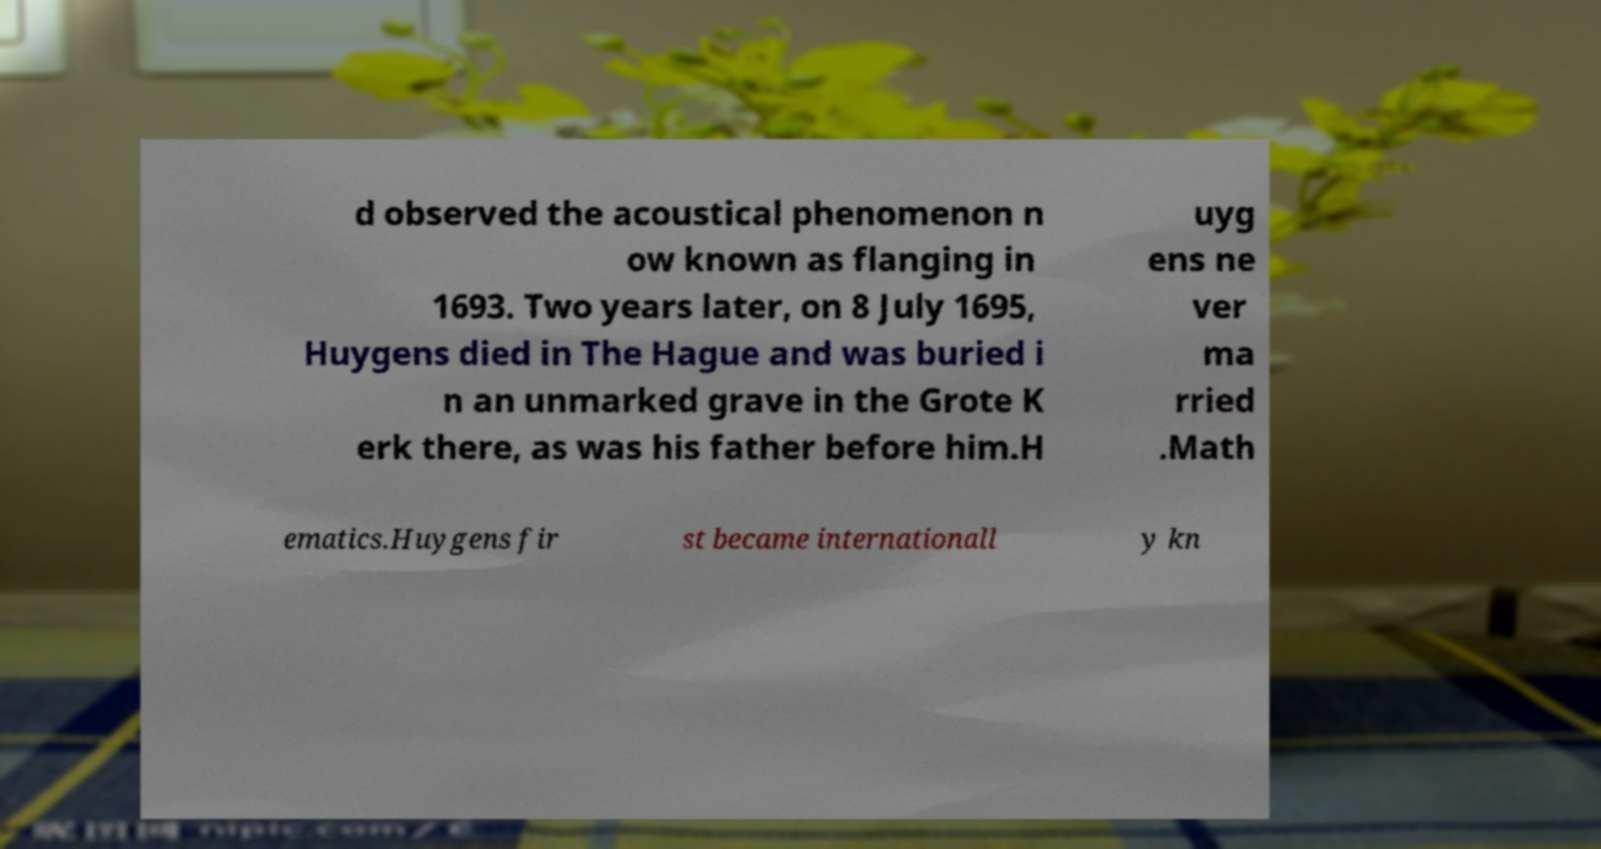Could you assist in decoding the text presented in this image and type it out clearly? d observed the acoustical phenomenon n ow known as flanging in 1693. Two years later, on 8 July 1695, Huygens died in The Hague and was buried i n an unmarked grave in the Grote K erk there, as was his father before him.H uyg ens ne ver ma rried .Math ematics.Huygens fir st became internationall y kn 